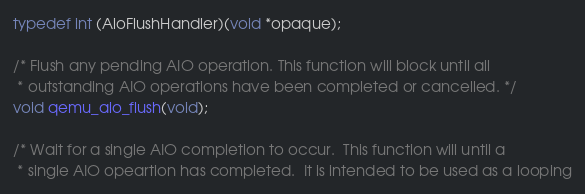Convert code to text. <code><loc_0><loc_0><loc_500><loc_500><_C_>typedef int (AioFlushHandler)(void *opaque);

/* Flush any pending AIO operation. This function will block until all
 * outstanding AIO operations have been completed or cancelled. */
void qemu_aio_flush(void);

/* Wait for a single AIO completion to occur.  This function will until a
 * single AIO opeartion has completed.  It is intended to be used as a looping</code> 